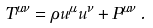<formula> <loc_0><loc_0><loc_500><loc_500>T ^ { \mu \nu } = \rho u ^ { \mu } u ^ { \nu } + P ^ { \mu \nu } \, .</formula> 